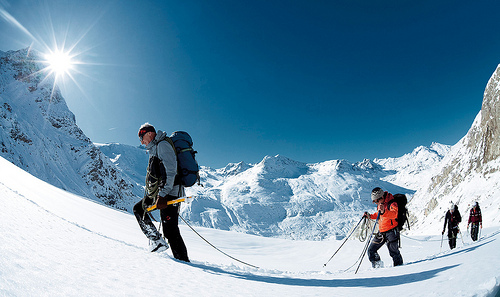<image>
Is there a man on the mountain? Yes. Looking at the image, I can see the man is positioned on top of the mountain, with the mountain providing support. 